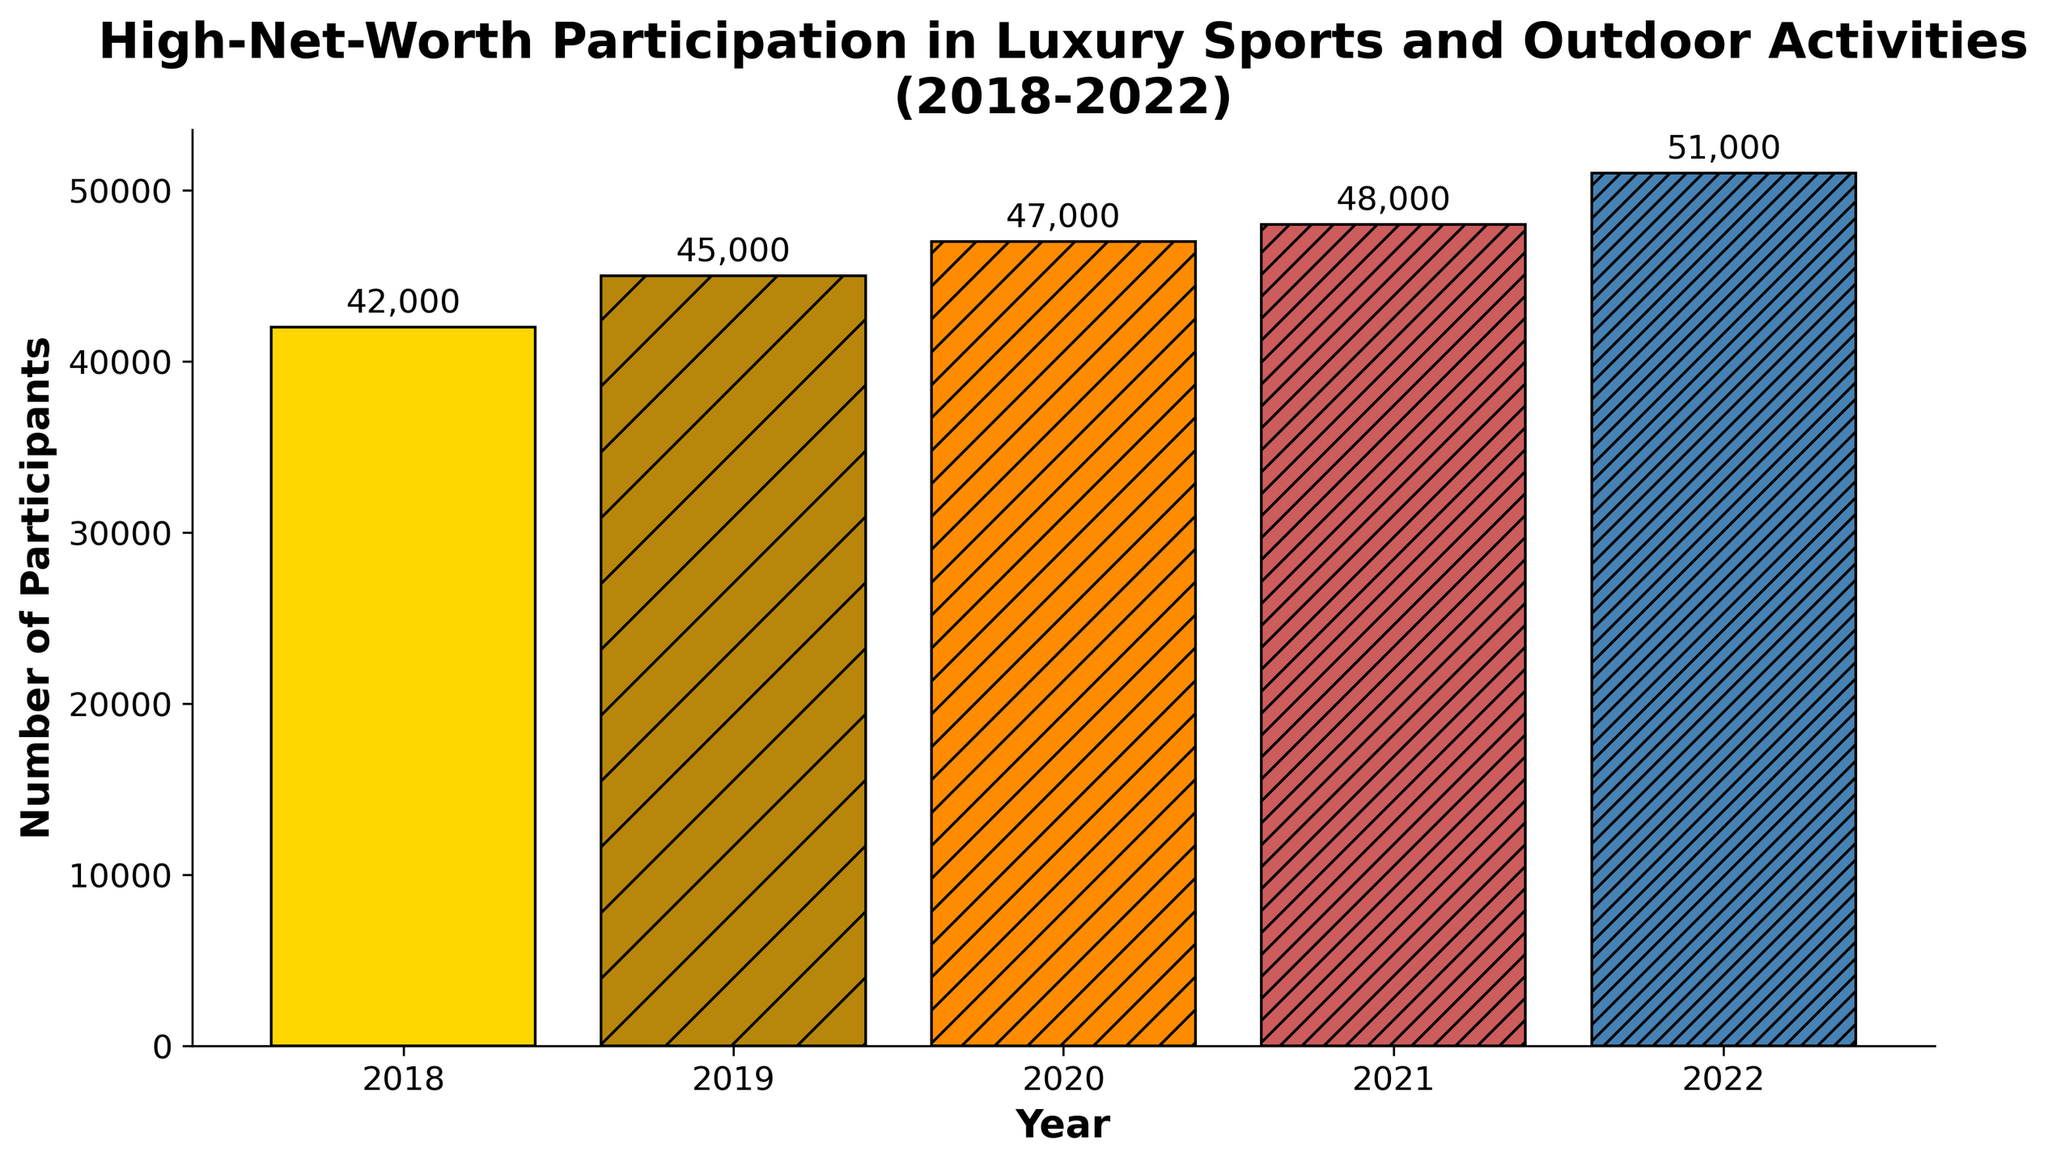What's the number of participants for the year 2020? Refer to the figure and locate the bar corresponding to the year 2020; observe the height of the bar labeled with the number of participants.
Answer: 47000 What's the total number of participants from 2018 to 2022? Sum the numbers of participants for each year: 42000 + 45000 + 47000 + 48000 + 51000 = 233000.
Answer: 233000 How many more participants were there in 2022 compared to 2018? Subtract the number of participants in 2018 from the number of participants in 2022: 51000 - 42000 = 9000.
Answer: 9000 In which year did the number of participants first exceed 47000? Examine the heights of the bars for each year and identify the first year where the height exceeds 47000. The bar for 2021 has 48000 participants, which is the first occurrence above 47000.
Answer: 2021 Which year experienced the largest increase in participants compared to the previous year, and what was the increment? Compare the differences in participants between consecutive years: 2022-2021: 3000; 2021-2020: 1000; 2020-2019: 2000; 2019-2018: 3000. The years 2019 to 2020 and 2021 to 2022 both saw the largest increment of 3000.
Answer: 2019-2020, 2021-2022; 3000 What is the average number of participants from 2018 to 2022? Calculate the average by dividing the total number of participants (233000) by the number of years (5): 233000 / 5 = 46600.
Answer: 46600 Which year had the lowest number of participants and what was the number? Identify the shortest bar in the figure, which corresponds to the year 2018 with 42000 participants.
Answer: 2018; 42000 Rank the years from the highest to the lowest number of participants. Compare the heights of the bars and list the years in descending order of participants: 2022, 2021, 2020, 2019, 2018.
Answer: 2022, 2021, 2020, 2019, 2018 What is the combined number of participants for the first and last years shown in the figure? Add the numbers of participants for 2018 and 2022: 42000 + 51000 = 93000.
Answer: 93000 